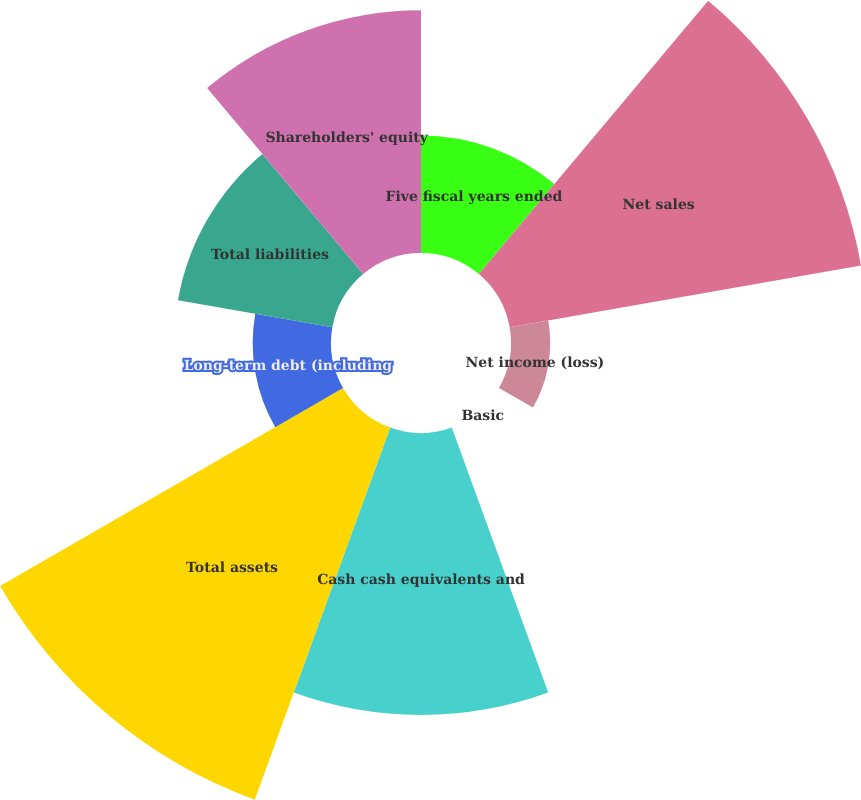Convert chart to OTSL. <chart><loc_0><loc_0><loc_500><loc_500><pie_chart><fcel>Five fiscal years ended<fcel>Net sales<fcel>Net income (loss)<fcel>Basic<fcel>Cash cash equivalents and<fcel>Total assets<fcel>Long-term debt (including<fcel>Total liabilities<fcel>Shareholders' equity<nl><fcel>7.04%<fcel>21.37%<fcel>2.35%<fcel>0.0%<fcel>16.89%<fcel>23.72%<fcel>4.69%<fcel>9.39%<fcel>14.54%<nl></chart> 